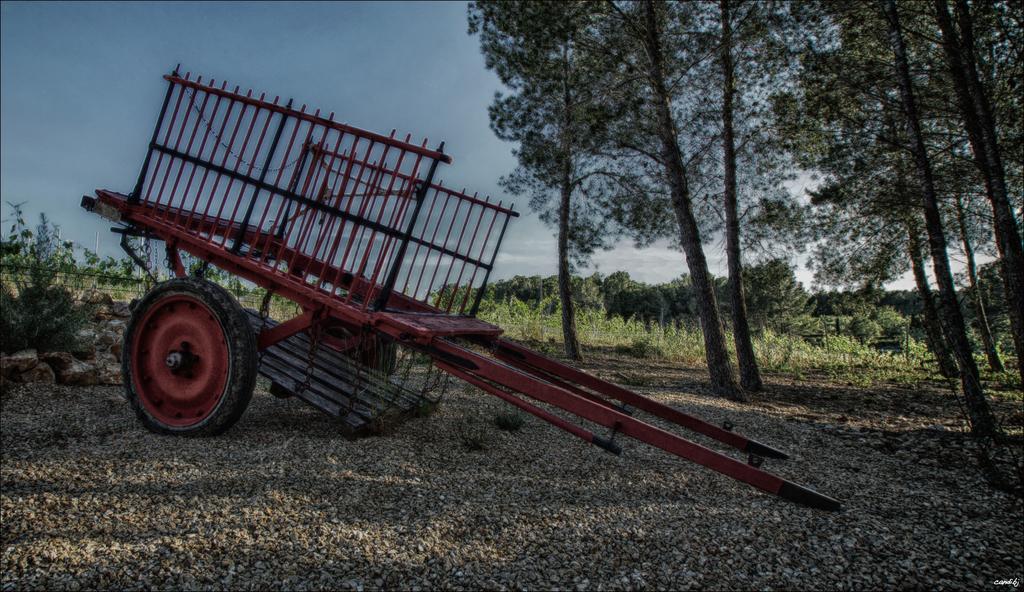How would you summarize this image in a sentence or two? In this image we can see a cart on the surface of a ground. In the background of the image we can see there are trees and sky. 